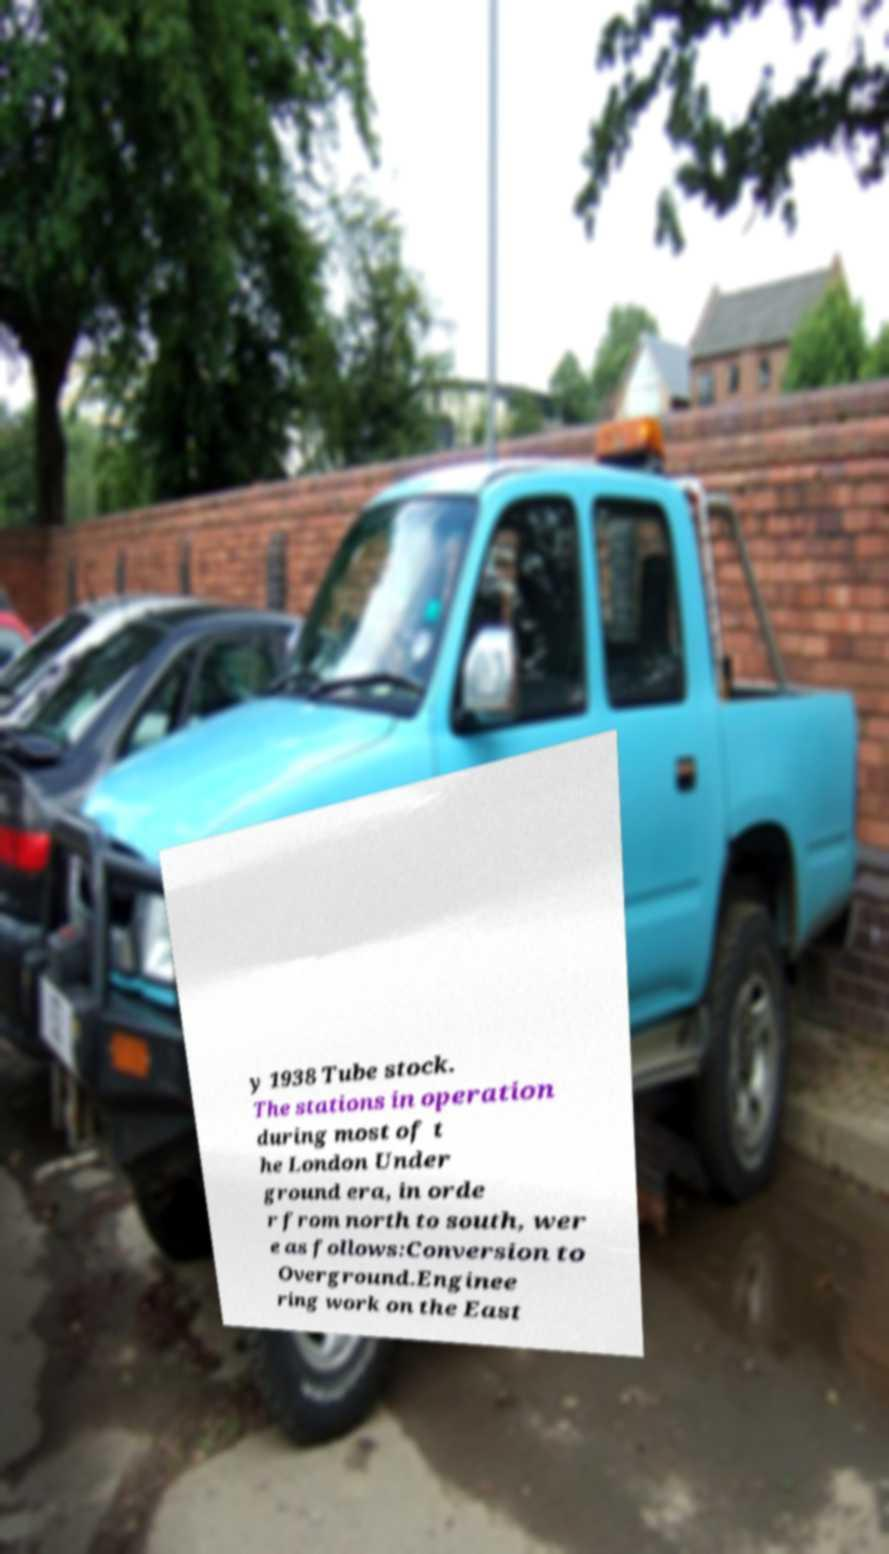Can you read and provide the text displayed in the image?This photo seems to have some interesting text. Can you extract and type it out for me? y 1938 Tube stock. The stations in operation during most of t he London Under ground era, in orde r from north to south, wer e as follows:Conversion to Overground.Enginee ring work on the East 